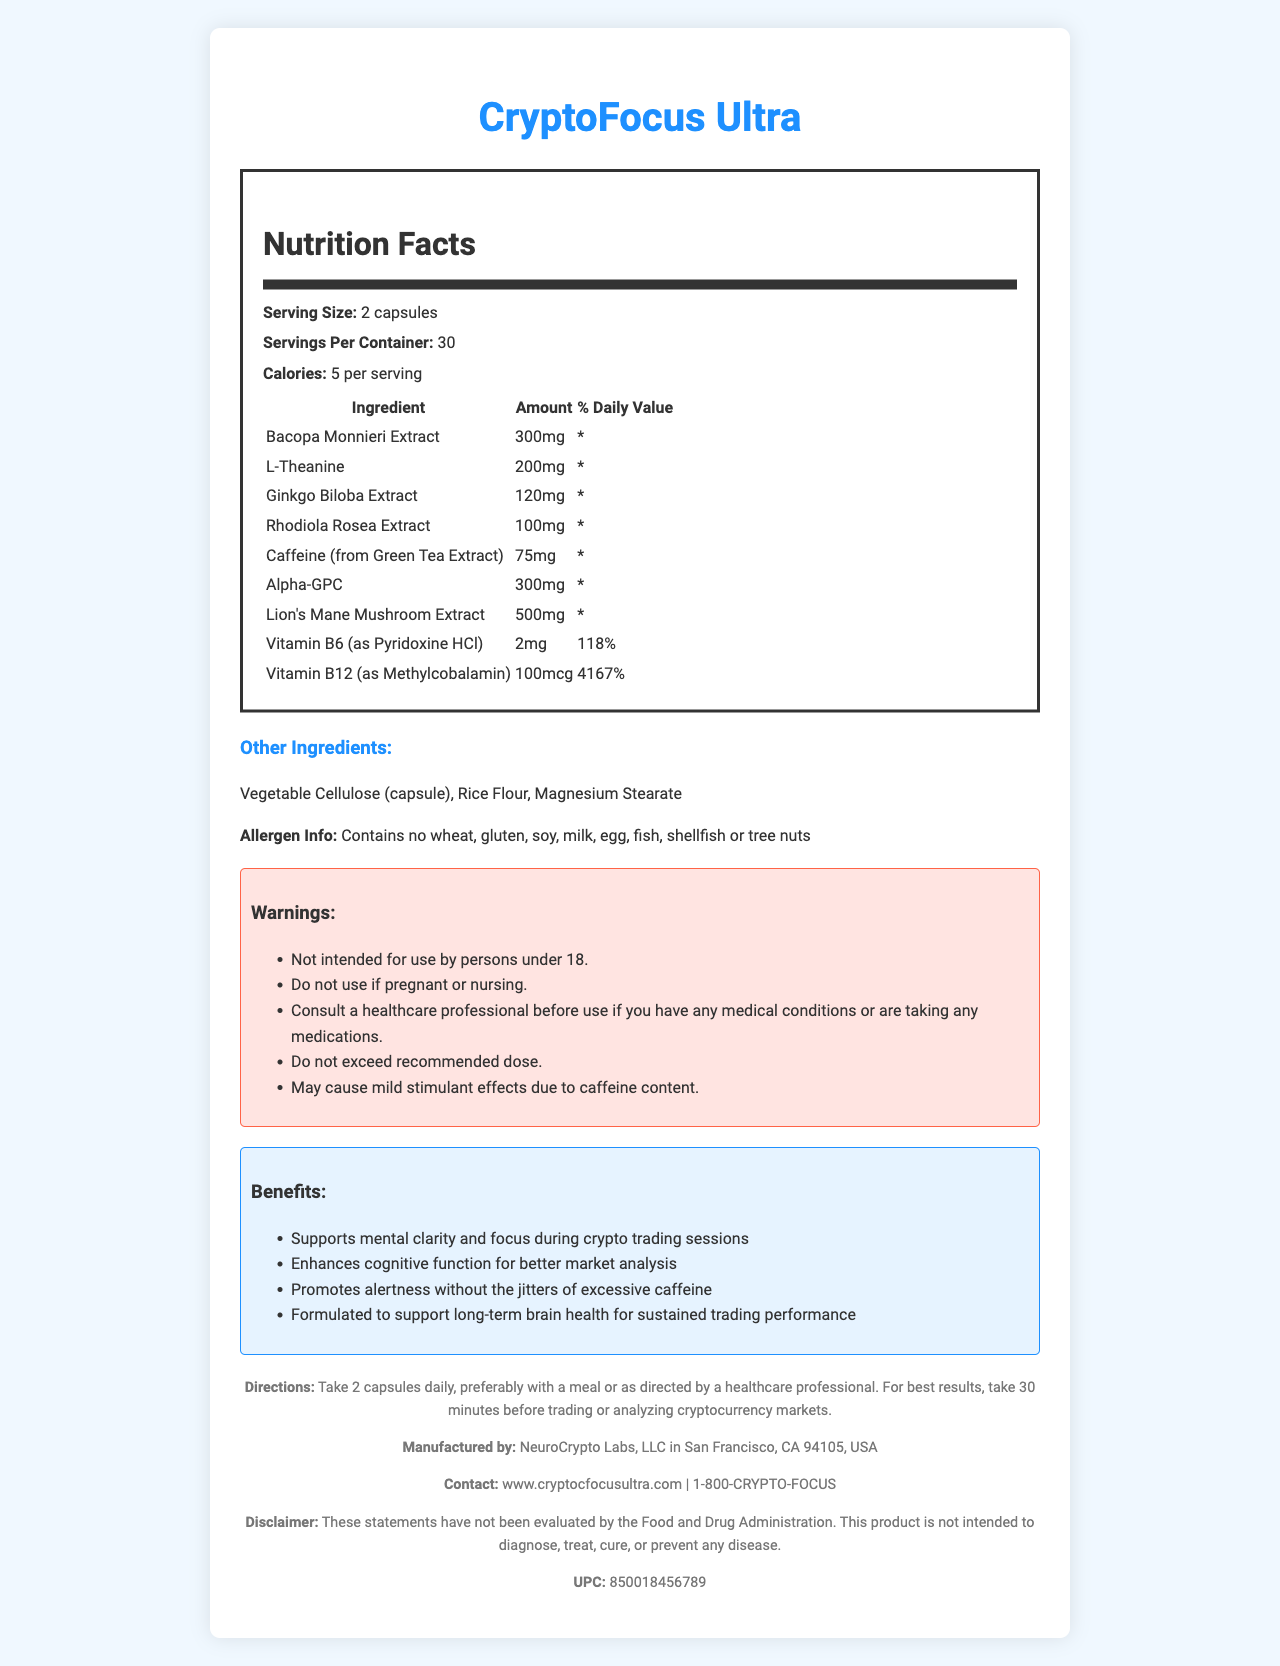What is the serving size for CryptoFocus Ultra? The document states that the serving size is 2 capsules.
Answer: 2 capsules How many calories are there per serving of CryptoFocus Ultra? The document indicates that each serving contains 5 calories.
Answer: 5 calories Which ingredient in CryptoFocus Ultra has the highest dosage? The document lists Lion's Mane Mushroom Extract as having the highest dosage at 500mg.
Answer: Lion's Mane Mushroom Extract (500mg) Is CryptoFocus Ultra free from allergens like wheat or soy? The allergen info in the document specifies that the product contains no wheat, gluten, soy, milk, egg, fish, shellfish, or tree nuts.
Answer: Yes How many servings are there per container of CryptoFocus Ultra? The document states that there are 30 servings per container.
Answer: 30 servings What is the dosage of Alpha-GPC in CryptoFocus Ultra? The document provides the dosage of Alpha-GPC as 300mg.
Answer: 300mg What is the suggested time to take CryptoFocus Ultra for optimal results? The directions suggest taking the supplement 30 minutes before trading or analyzing cryptocurrency markets for best results.
Answer: 30 minutes before trading or analyzing cryptocurrency markets What is the percentage daily value of Vitamin B12 in CryptoFocus Ultra? A. 100% B. 500% C. 1000% D. 4167% The document states that the daily value of Vitamin B12 in one serving is 4167%.
Answer: D. 4167% Which ingredient in CryptoFocus Ultra can cause mild stimulant effects? A. Rhodiola Rosea Extract B. Bacopa Monnieri Extract C. Caffeine (from Green Tea Extract) D. L-Theanine The warnings section mentions that the product may cause mild stimulant effects due to caffeine content.
Answer: C. Caffeine (from Green Tea Extract) Can persons under 18 years of age use CryptoFocus Ultra? The warnings specify that the product is not intended for use by persons under 18.
Answer: No Summarize the main idea of the document. The document details the ingredients, servings, benefits, directions for use, allergen information, warnings, manufacturing details, and a disclaimer for CryptoFocus Ultra.
Answer: CryptoFocus Ultra is a dietary supplement designed to enhance mental clarity and focus, particularly for cryptocurrency trading. It contains various brain-boosting ingredients, provides specific serving information, and includes warnings and usage directions. It is manufactured by NeuroCrypto Labs and is allergen-free. What is the molecular structure of L-Theanine? The document does not provide details about the molecular structure of L-Theanine.
Answer: Not enough information 